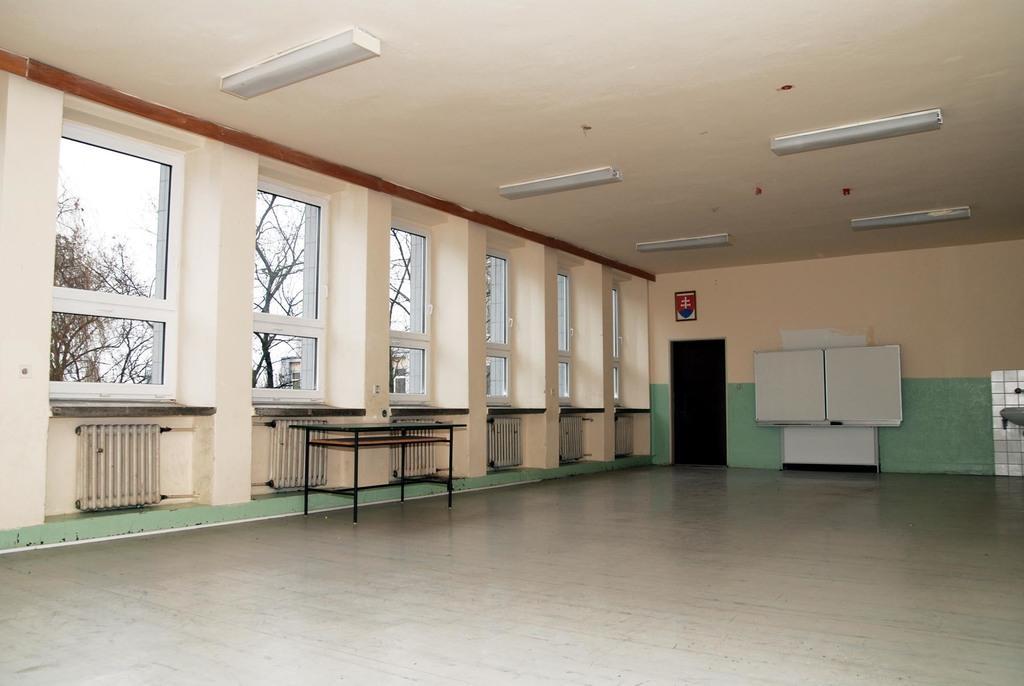Could you give a brief overview of what you see in this image? In the picture we can see room, there is table, on right side of the picture there is board, door and there is a wall and in the background of the picture there are some windows through which we can see some trees. 